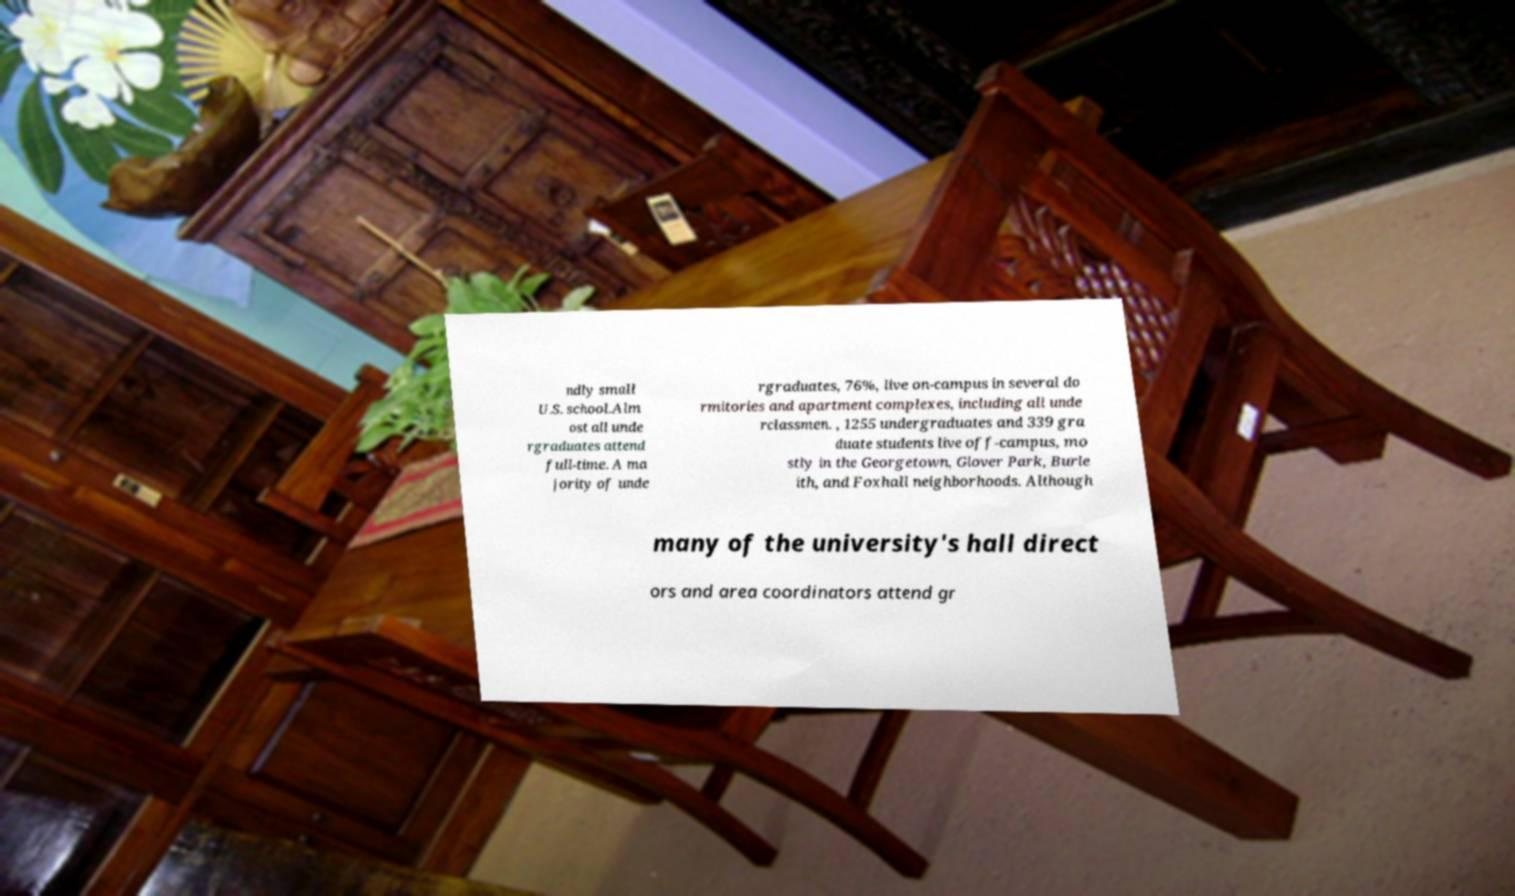Can you read and provide the text displayed in the image?This photo seems to have some interesting text. Can you extract and type it out for me? ndly small U.S. school.Alm ost all unde rgraduates attend full-time. A ma jority of unde rgraduates, 76%, live on-campus in several do rmitories and apartment complexes, including all unde rclassmen. , 1255 undergraduates and 339 gra duate students live off-campus, mo stly in the Georgetown, Glover Park, Burle ith, and Foxhall neighborhoods. Although many of the university's hall direct ors and area coordinators attend gr 